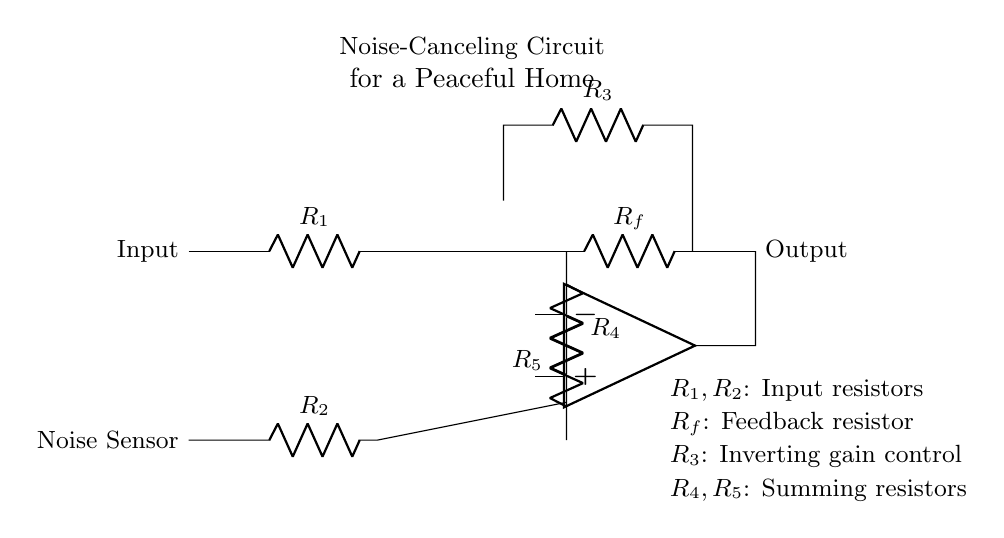What is the main purpose of this circuit? The main purpose of the circuit is to cancel noise, creating a more peaceful home environment. This can be inferred from the labeled title of the circuit diagram.
Answer: Noise cancellation What is the type of the main amplifier used in this circuit? The main amplifier used in the circuit is an operational amplifier, as indicated by the symbol present in the circuit diagram.
Answer: Operational amplifier How many resistors are present in the noise-canceling circuit? There are five resistors in total: R1, R2, R3, R4, and R5, which can be counted directly from the components shown in the circuit diagram.
Answer: Five What does resistor R_f represent in this circuit? Resistor R_f serves as a feedback resistor, influencing the gain of the operational amplifier in the circuit. This is indicated by its label and position within the feedback loop.
Answer: Feedback resistor What kind of configuration is used for the noise sensing path? The noise sensing path utilizes a voltage divider and inverting amplifier configuration made up of R2 and the operational amplifier directly, which detects and amplifies noise.
Answer: Inverting amplifier configuration Which resistors are part of the summing point for noise cancellation? The summing point for noise cancellation includes resistors R4 and R5, as they are directly connected to the output of both the main and noise sensing paths.
Answer: R4 and R5 